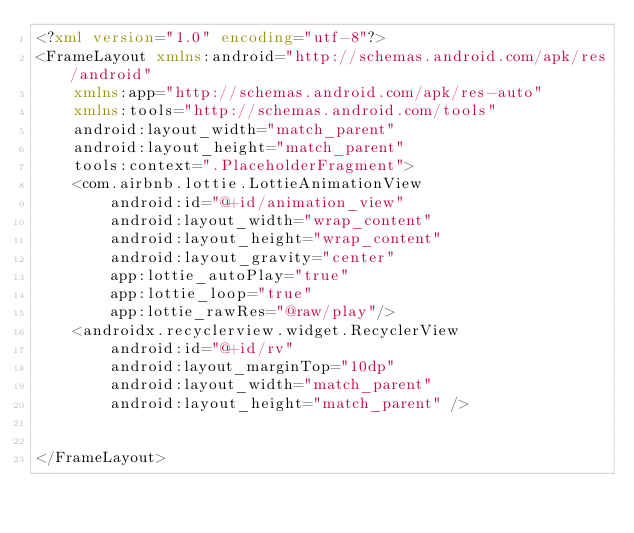<code> <loc_0><loc_0><loc_500><loc_500><_XML_><?xml version="1.0" encoding="utf-8"?>
<FrameLayout xmlns:android="http://schemas.android.com/apk/res/android"
    xmlns:app="http://schemas.android.com/apk/res-auto"
    xmlns:tools="http://schemas.android.com/tools"
    android:layout_width="match_parent"
    android:layout_height="match_parent"
    tools:context=".PlaceholderFragment">
    <com.airbnb.lottie.LottieAnimationView
        android:id="@+id/animation_view"
        android:layout_width="wrap_content"
        android:layout_height="wrap_content"
        android:layout_gravity="center"
        app:lottie_autoPlay="true"
        app:lottie_loop="true"
        app:lottie_rawRes="@raw/play"/>
    <androidx.recyclerview.widget.RecyclerView
        android:id="@+id/rv"
        android:layout_marginTop="10dp"
        android:layout_width="match_parent"
        android:layout_height="match_parent" />


</FrameLayout></code> 